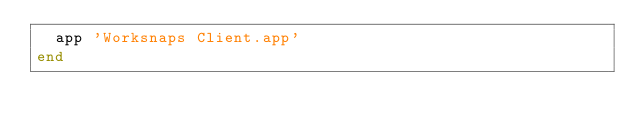Convert code to text. <code><loc_0><loc_0><loc_500><loc_500><_Ruby_>  app 'Worksnaps Client.app'
end
</code> 